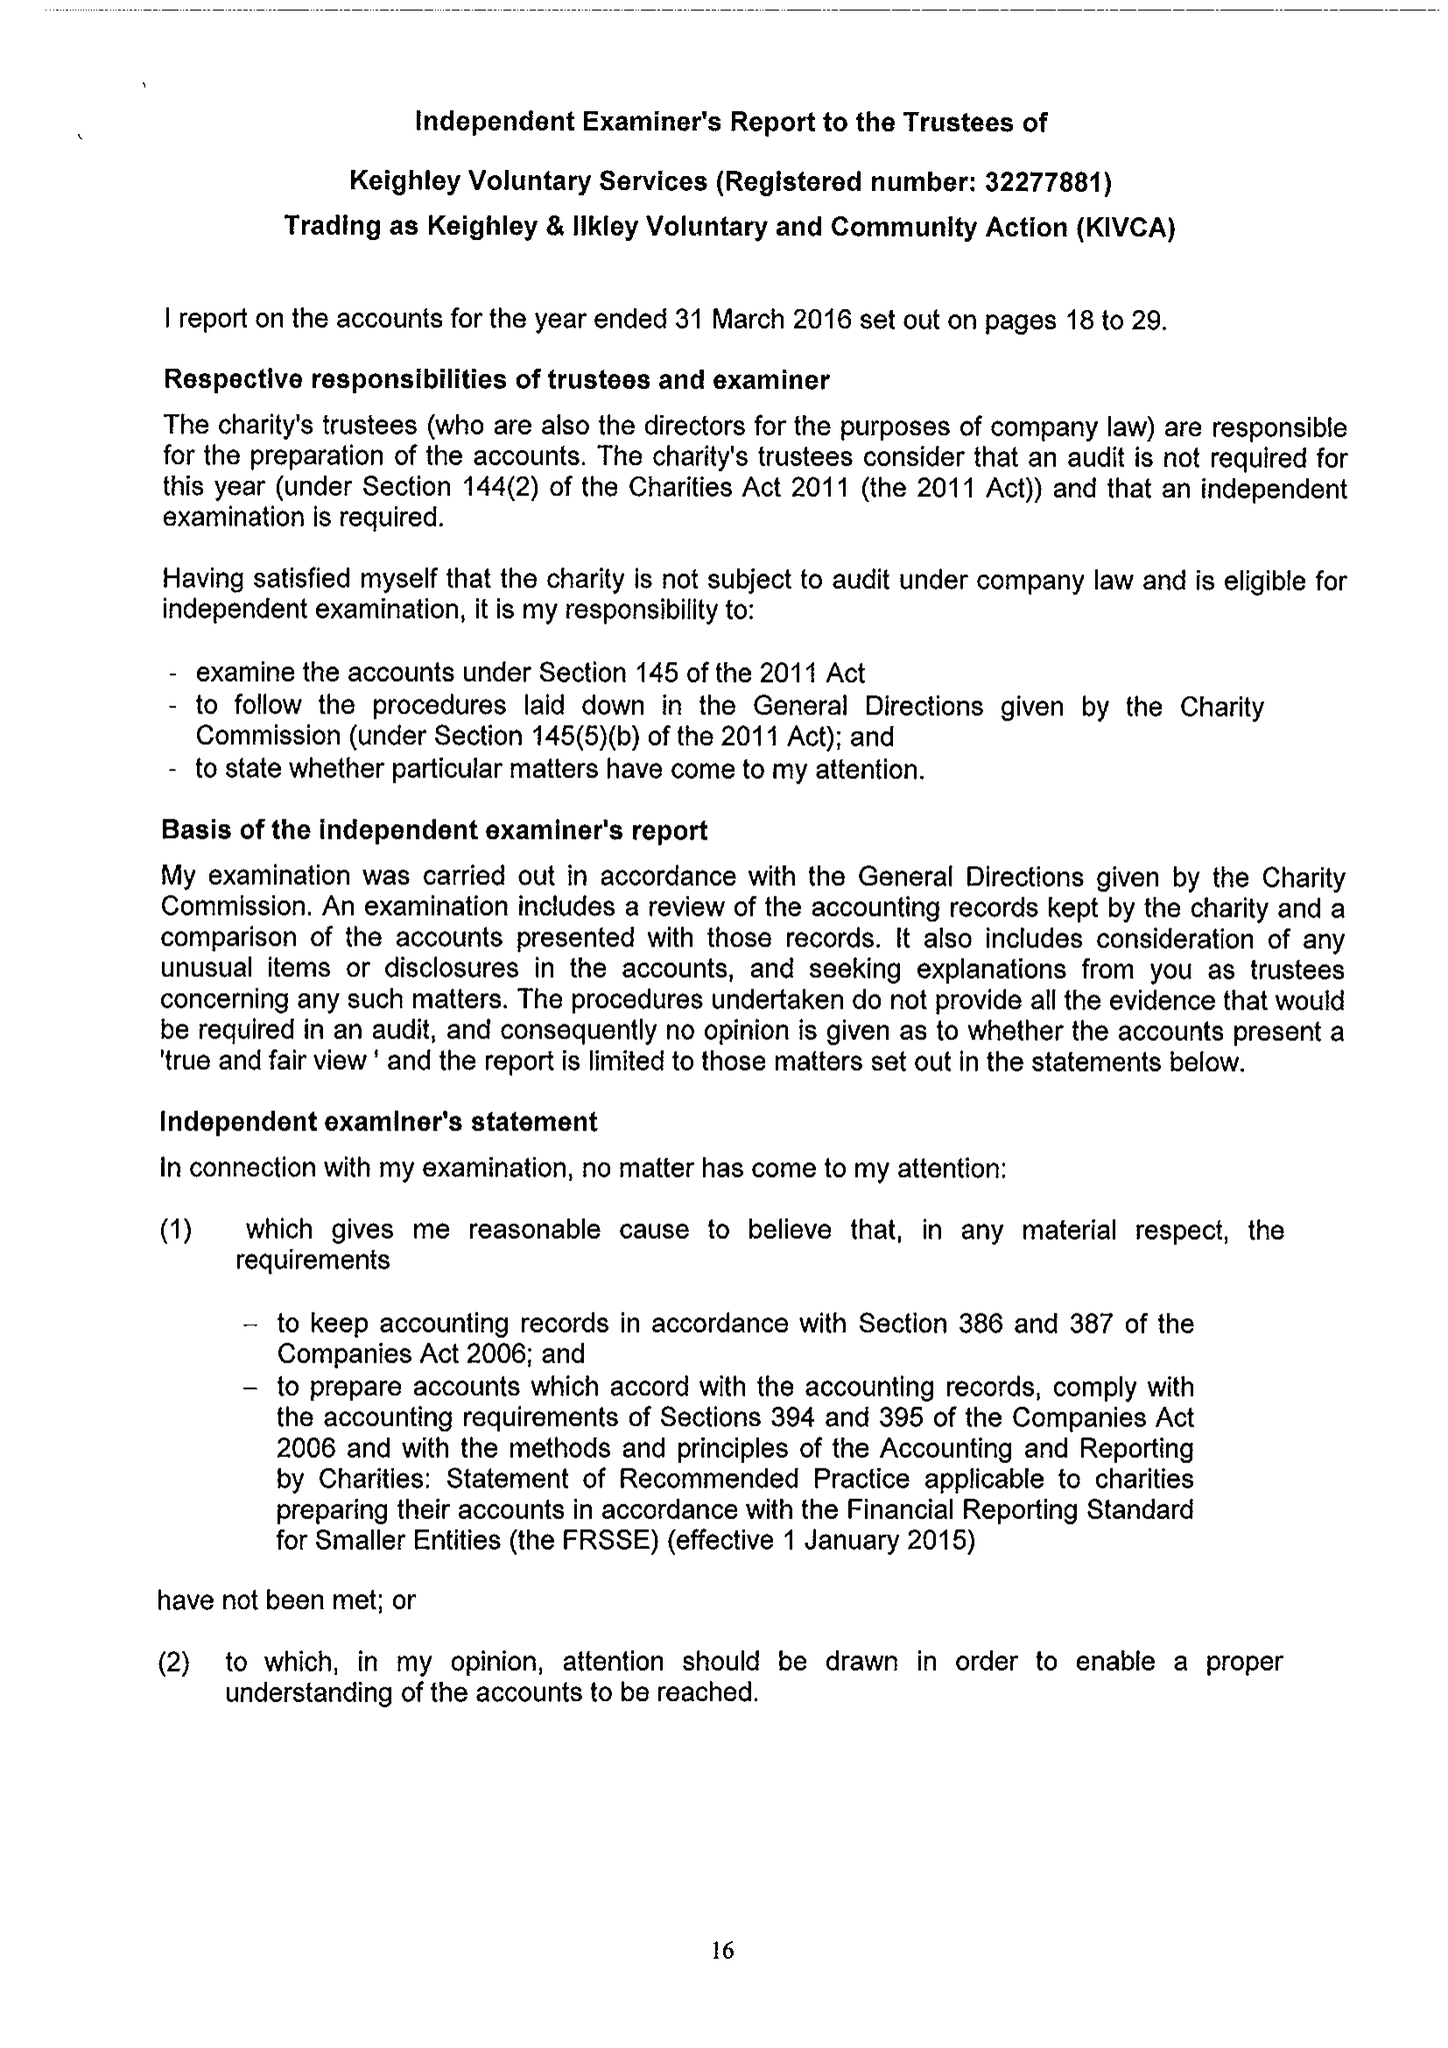What is the value for the spending_annually_in_british_pounds?
Answer the question using a single word or phrase. 765334.00 